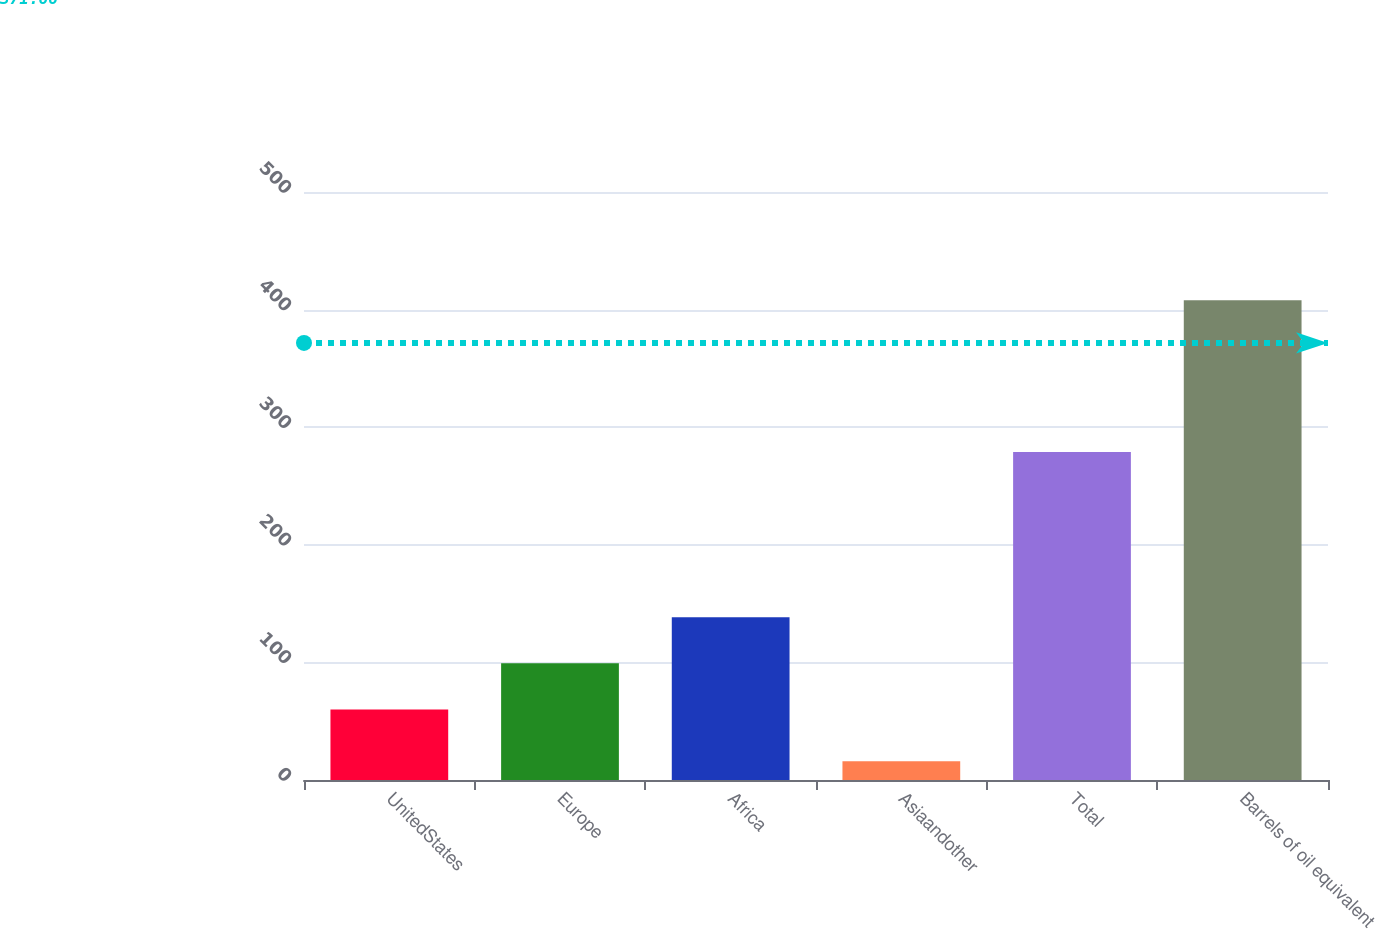<chart> <loc_0><loc_0><loc_500><loc_500><bar_chart><fcel>UnitedStates<fcel>Europe<fcel>Africa<fcel>Asiaandother<fcel>Total<fcel>Barrels of oil equivalent<nl><fcel>60<fcel>99.2<fcel>138.4<fcel>16<fcel>279<fcel>408<nl></chart> 